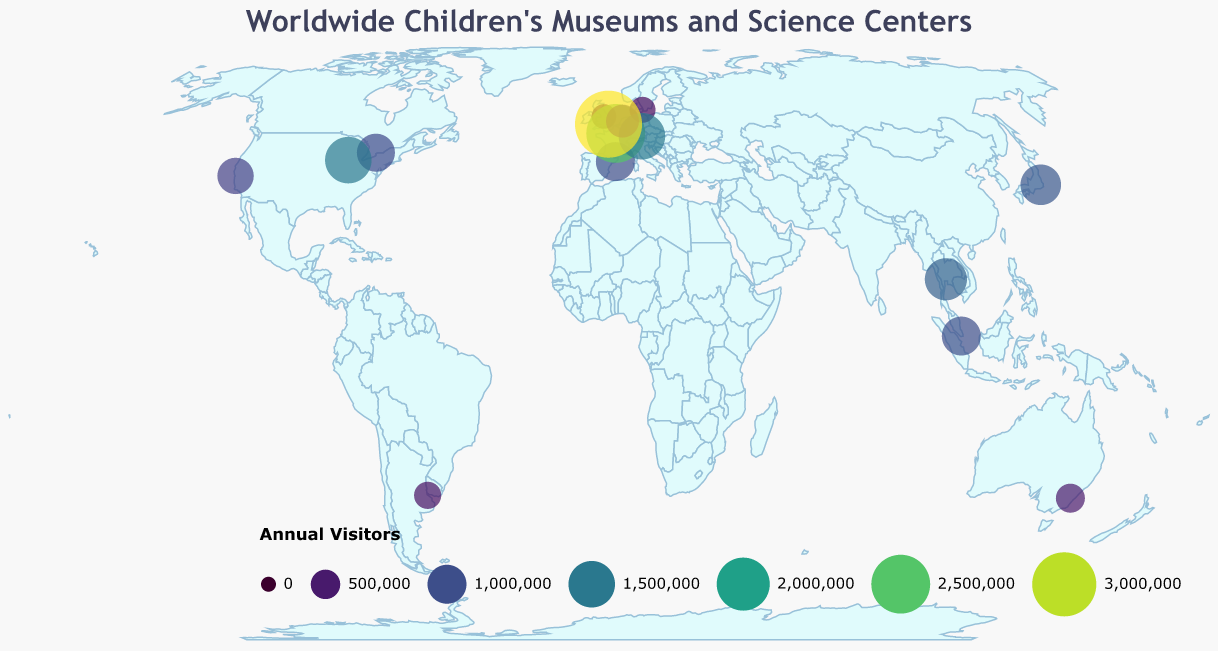Which museum has the highest number of annual visitors? By observing the size and color of the circles in the plot, the Science Museum in London stands out as having the largest circle, indicating the highest number of annual visitors.
Answer: Science Museum in London Which city in the United States has the most visitor numbers to its children's museum or science center? The figure shows data for two U.S. cities: San Francisco (Exploratorium) and Chicago (Museum of Science and Industry). By comparing the size and color of the circles, the Chicago museum appears larger with more visitors.
Answer: Chicago Among CosmoCaixa and the Deutsches Museum, which has more annual visitors and by how much? CosmoCaixa (Barcelona) and the Deutsches Museum (Munich) are represented. The Deutsches Museum has 1,500,000 visitors, and CosmoCaixa has 1,000,000. The difference is calculated by subtracting the two: 1,500,000 - 1,000,000.
Answer: Deutsches Museum, 500,000 more What is the average number of annual visitors for children's museums in the United Kingdom? The UK has two entries: Eureka! The National Children's Museum with 300,000 and the Science Museum in London with 3,300,000 visitors. The sum is 300,000 + 3,300,000 = 3,600,000. Dividing by 2 gives the average: 3,600,000 / 2.
Answer: 1,800,000 Which continent has the highest combined number of annual visitors across all museums and science centers listed in the data? The continents represented are North America, Europe, South America, Asia, and Australia. Summing the annual visitors for each continent, Europe has the highest combined visitors due to several high-visitor museums: Paris, London, Munich, etc.
Answer: Europe How does the combined annual visitors of Japanese children's museums compare to those in Singapore? The figure features the Miraikan in Tokyo with 1,100,000 visitors and Science Centre Singapore with 1,000,000 visitors. Comparing these numbers, Japan has more visitors by subtracting: 1,100,000 - 1,000,000.
Answer: Japan, 100,000 more Identify the museum with the least number of annual visitors and its location. By looking at the smallest circle and considering the color gradient, Eureka! The National Children's Museum in Halifax, United Kingdom, is identified as having the least visitors.
Answer: Eureka! The National Children's Museum, Halifax What is the total number of annual visitors across all the children's museums and science centers in the plot? Summing up all the annual visitors from each entry: 850,000 + 300,000 + 1,000,000 + 400,000 + 1,200,000 + 2,500,000 + 350,000 + 1,000,000 + 950,000 + 1,500,000 + 670,000 + 1,100,000 + 480,000 + 3,300,000 + 1,500,000 gives the total.
Answer: 16,100,000 Which museum appears to have a circle size that indicates it has over 2 million annual visitors? In the plot, the larger circles associated with over 2 million visitors belong to Cité des Sciences et de l'Industrie in Paris and the Science Museum in London.
Answer: Cité des Sciences et de l'Industrie and Science Museum 